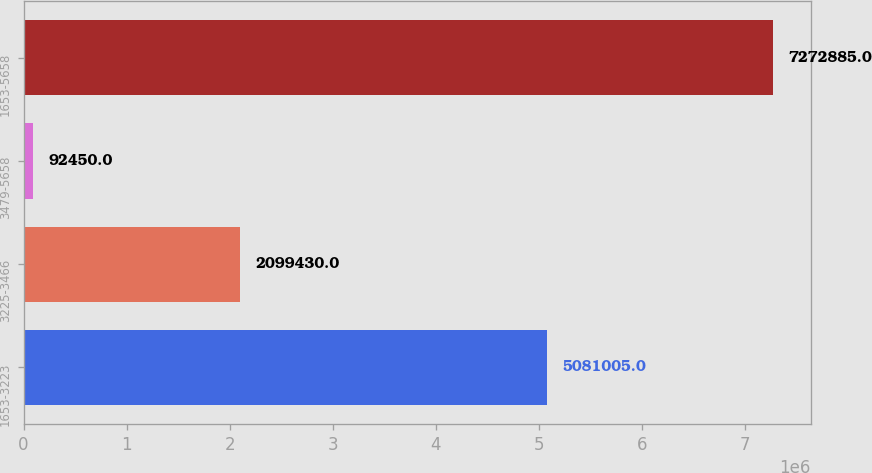Convert chart. <chart><loc_0><loc_0><loc_500><loc_500><bar_chart><fcel>1653-3223<fcel>3225-3466<fcel>3479-5658<fcel>1653-5658<nl><fcel>5.081e+06<fcel>2.09943e+06<fcel>92450<fcel>7.27288e+06<nl></chart> 